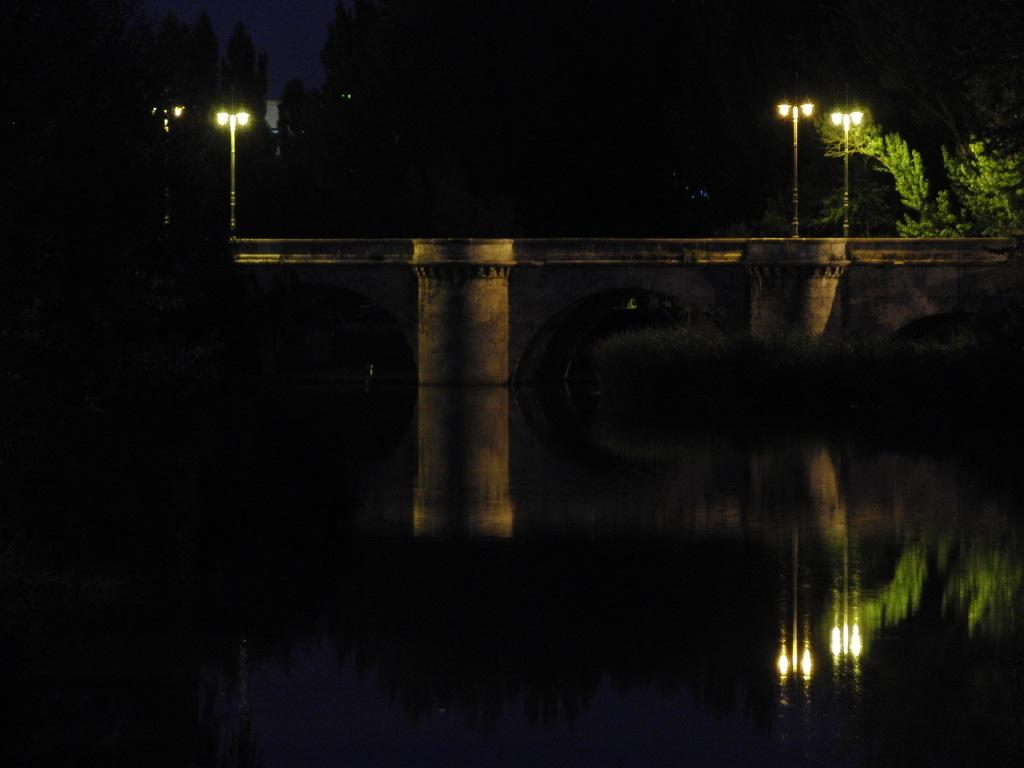What type of natural feature is present in the image? There is a river in the image. What structure can be seen in the background? There is a bridge in the background of the image. What type of vegetation is on the right side of the image? There is a tree on the right side of the image. What are the poles with lights used for in the image? The poles with lights are likely used for illumination. How would you describe the overall lighting in the image? The rest of the image is dark, with the exception of the lights on the poles. What type of glove is the aunt wearing in the image? There is no aunt or glove present in the image. 